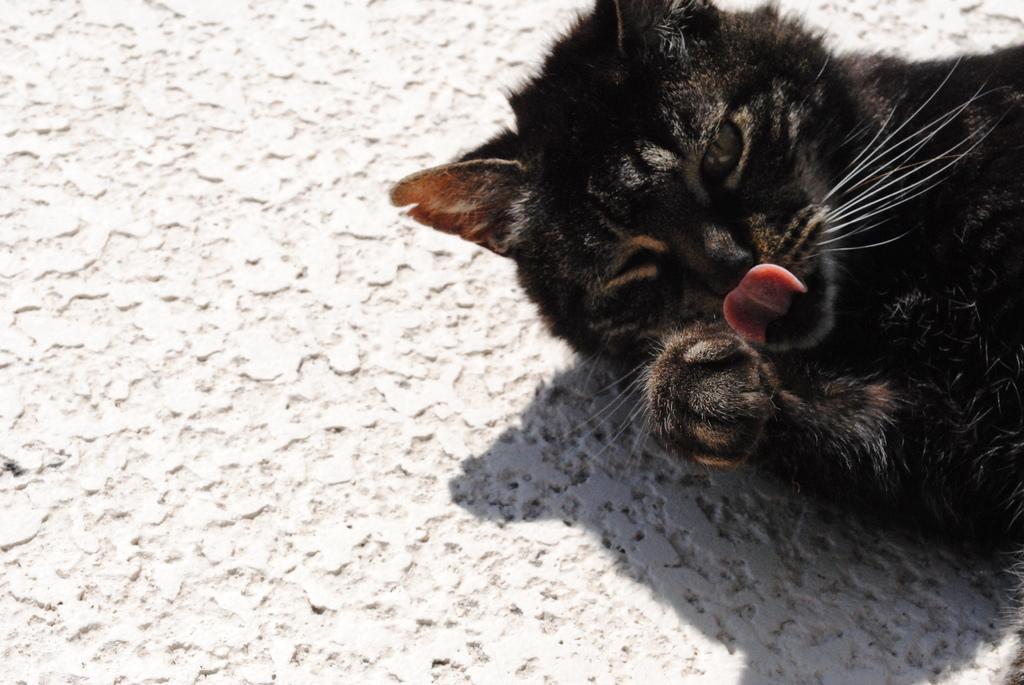Could you give a brief overview of what you see in this image? In the image there is a black cat and there is a white surface around the cat. 